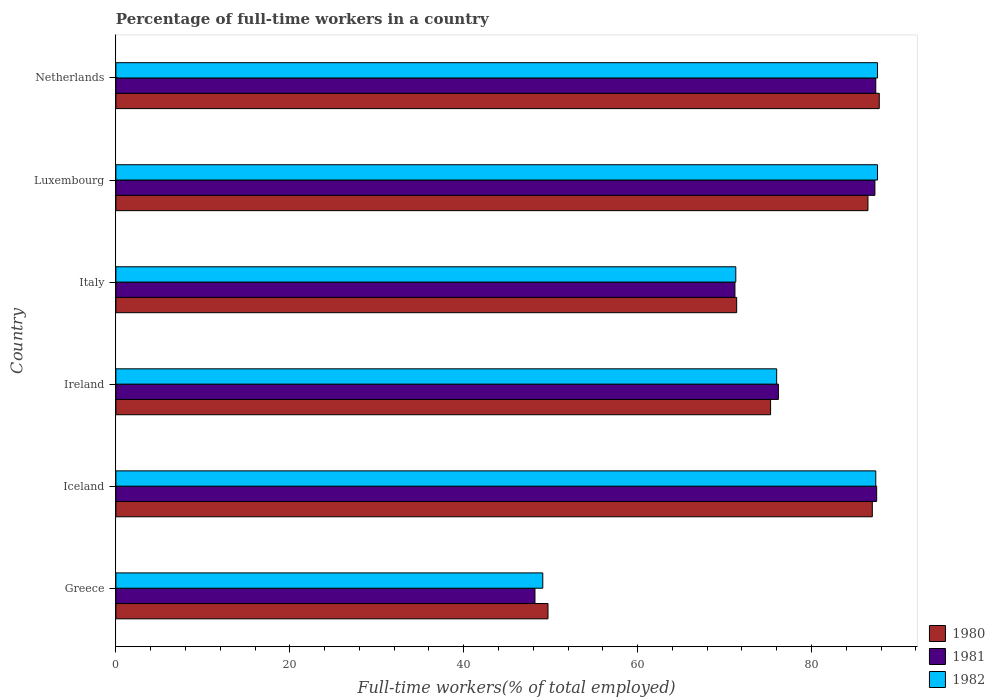Are the number of bars per tick equal to the number of legend labels?
Your answer should be compact. Yes. How many bars are there on the 4th tick from the top?
Ensure brevity in your answer.  3. How many bars are there on the 5th tick from the bottom?
Offer a very short reply. 3. What is the label of the 2nd group of bars from the top?
Your answer should be compact. Luxembourg. What is the percentage of full-time workers in 1981 in Greece?
Make the answer very short. 48.2. Across all countries, what is the maximum percentage of full-time workers in 1982?
Offer a terse response. 87.6. Across all countries, what is the minimum percentage of full-time workers in 1981?
Keep it short and to the point. 48.2. In which country was the percentage of full-time workers in 1980 maximum?
Keep it short and to the point. Netherlands. In which country was the percentage of full-time workers in 1982 minimum?
Ensure brevity in your answer.  Greece. What is the total percentage of full-time workers in 1980 in the graph?
Your answer should be compact. 457.7. What is the difference between the percentage of full-time workers in 1981 in Iceland and that in Ireland?
Your answer should be compact. 11.3. What is the difference between the percentage of full-time workers in 1981 in Italy and the percentage of full-time workers in 1982 in Netherlands?
Make the answer very short. -16.4. What is the average percentage of full-time workers in 1980 per country?
Offer a terse response. 76.28. What is the difference between the percentage of full-time workers in 1981 and percentage of full-time workers in 1980 in Luxembourg?
Provide a succinct answer. 0.8. In how many countries, is the percentage of full-time workers in 1981 greater than 12 %?
Your answer should be compact. 6. What is the ratio of the percentage of full-time workers in 1982 in Greece to that in Italy?
Offer a terse response. 0.69. Is the difference between the percentage of full-time workers in 1981 in Greece and Italy greater than the difference between the percentage of full-time workers in 1980 in Greece and Italy?
Provide a succinct answer. No. What is the difference between the highest and the second highest percentage of full-time workers in 1980?
Keep it short and to the point. 0.8. What is the difference between the highest and the lowest percentage of full-time workers in 1982?
Make the answer very short. 38.5. Is the sum of the percentage of full-time workers in 1980 in Italy and Luxembourg greater than the maximum percentage of full-time workers in 1981 across all countries?
Offer a terse response. Yes. Is it the case that in every country, the sum of the percentage of full-time workers in 1982 and percentage of full-time workers in 1981 is greater than the percentage of full-time workers in 1980?
Provide a succinct answer. Yes. How many bars are there?
Keep it short and to the point. 18. How many countries are there in the graph?
Ensure brevity in your answer.  6. What is the difference between two consecutive major ticks on the X-axis?
Your answer should be compact. 20. Does the graph contain any zero values?
Offer a terse response. No. How are the legend labels stacked?
Your answer should be very brief. Vertical. What is the title of the graph?
Offer a terse response. Percentage of full-time workers in a country. Does "2002" appear as one of the legend labels in the graph?
Give a very brief answer. No. What is the label or title of the X-axis?
Give a very brief answer. Full-time workers(% of total employed). What is the label or title of the Y-axis?
Your answer should be compact. Country. What is the Full-time workers(% of total employed) of 1980 in Greece?
Offer a terse response. 49.7. What is the Full-time workers(% of total employed) of 1981 in Greece?
Offer a terse response. 48.2. What is the Full-time workers(% of total employed) of 1982 in Greece?
Provide a succinct answer. 49.1. What is the Full-time workers(% of total employed) of 1981 in Iceland?
Make the answer very short. 87.5. What is the Full-time workers(% of total employed) of 1982 in Iceland?
Keep it short and to the point. 87.4. What is the Full-time workers(% of total employed) of 1980 in Ireland?
Your answer should be very brief. 75.3. What is the Full-time workers(% of total employed) in 1981 in Ireland?
Offer a very short reply. 76.2. What is the Full-time workers(% of total employed) of 1980 in Italy?
Provide a succinct answer. 71.4. What is the Full-time workers(% of total employed) of 1981 in Italy?
Keep it short and to the point. 71.2. What is the Full-time workers(% of total employed) of 1982 in Italy?
Keep it short and to the point. 71.3. What is the Full-time workers(% of total employed) of 1980 in Luxembourg?
Make the answer very short. 86.5. What is the Full-time workers(% of total employed) in 1981 in Luxembourg?
Give a very brief answer. 87.3. What is the Full-time workers(% of total employed) of 1982 in Luxembourg?
Offer a very short reply. 87.6. What is the Full-time workers(% of total employed) in 1980 in Netherlands?
Offer a terse response. 87.8. What is the Full-time workers(% of total employed) of 1981 in Netherlands?
Your response must be concise. 87.4. What is the Full-time workers(% of total employed) in 1982 in Netherlands?
Make the answer very short. 87.6. Across all countries, what is the maximum Full-time workers(% of total employed) of 1980?
Ensure brevity in your answer.  87.8. Across all countries, what is the maximum Full-time workers(% of total employed) of 1981?
Give a very brief answer. 87.5. Across all countries, what is the maximum Full-time workers(% of total employed) of 1982?
Your answer should be very brief. 87.6. Across all countries, what is the minimum Full-time workers(% of total employed) of 1980?
Offer a very short reply. 49.7. Across all countries, what is the minimum Full-time workers(% of total employed) in 1981?
Your answer should be very brief. 48.2. Across all countries, what is the minimum Full-time workers(% of total employed) in 1982?
Make the answer very short. 49.1. What is the total Full-time workers(% of total employed) of 1980 in the graph?
Your response must be concise. 457.7. What is the total Full-time workers(% of total employed) of 1981 in the graph?
Your answer should be very brief. 457.8. What is the total Full-time workers(% of total employed) of 1982 in the graph?
Your answer should be compact. 459. What is the difference between the Full-time workers(% of total employed) of 1980 in Greece and that in Iceland?
Make the answer very short. -37.3. What is the difference between the Full-time workers(% of total employed) of 1981 in Greece and that in Iceland?
Your answer should be compact. -39.3. What is the difference between the Full-time workers(% of total employed) in 1982 in Greece and that in Iceland?
Give a very brief answer. -38.3. What is the difference between the Full-time workers(% of total employed) in 1980 in Greece and that in Ireland?
Offer a very short reply. -25.6. What is the difference between the Full-time workers(% of total employed) in 1982 in Greece and that in Ireland?
Make the answer very short. -26.9. What is the difference between the Full-time workers(% of total employed) of 1980 in Greece and that in Italy?
Provide a succinct answer. -21.7. What is the difference between the Full-time workers(% of total employed) of 1982 in Greece and that in Italy?
Provide a short and direct response. -22.2. What is the difference between the Full-time workers(% of total employed) of 1980 in Greece and that in Luxembourg?
Ensure brevity in your answer.  -36.8. What is the difference between the Full-time workers(% of total employed) in 1981 in Greece and that in Luxembourg?
Offer a very short reply. -39.1. What is the difference between the Full-time workers(% of total employed) in 1982 in Greece and that in Luxembourg?
Make the answer very short. -38.5. What is the difference between the Full-time workers(% of total employed) in 1980 in Greece and that in Netherlands?
Your answer should be very brief. -38.1. What is the difference between the Full-time workers(% of total employed) of 1981 in Greece and that in Netherlands?
Your response must be concise. -39.2. What is the difference between the Full-time workers(% of total employed) in 1982 in Greece and that in Netherlands?
Provide a succinct answer. -38.5. What is the difference between the Full-time workers(% of total employed) of 1981 in Iceland and that in Ireland?
Give a very brief answer. 11.3. What is the difference between the Full-time workers(% of total employed) in 1982 in Iceland and that in Ireland?
Ensure brevity in your answer.  11.4. What is the difference between the Full-time workers(% of total employed) in 1981 in Iceland and that in Italy?
Make the answer very short. 16.3. What is the difference between the Full-time workers(% of total employed) in 1980 in Iceland and that in Luxembourg?
Provide a short and direct response. 0.5. What is the difference between the Full-time workers(% of total employed) of 1981 in Iceland and that in Luxembourg?
Give a very brief answer. 0.2. What is the difference between the Full-time workers(% of total employed) of 1980 in Iceland and that in Netherlands?
Give a very brief answer. -0.8. What is the difference between the Full-time workers(% of total employed) of 1981 in Iceland and that in Netherlands?
Offer a very short reply. 0.1. What is the difference between the Full-time workers(% of total employed) of 1980 in Ireland and that in Italy?
Give a very brief answer. 3.9. What is the difference between the Full-time workers(% of total employed) of 1981 in Ireland and that in Italy?
Your response must be concise. 5. What is the difference between the Full-time workers(% of total employed) in 1982 in Ireland and that in Italy?
Make the answer very short. 4.7. What is the difference between the Full-time workers(% of total employed) in 1980 in Ireland and that in Luxembourg?
Provide a succinct answer. -11.2. What is the difference between the Full-time workers(% of total employed) of 1982 in Ireland and that in Luxembourg?
Ensure brevity in your answer.  -11.6. What is the difference between the Full-time workers(% of total employed) of 1980 in Ireland and that in Netherlands?
Make the answer very short. -12.5. What is the difference between the Full-time workers(% of total employed) of 1982 in Ireland and that in Netherlands?
Your answer should be very brief. -11.6. What is the difference between the Full-time workers(% of total employed) of 1980 in Italy and that in Luxembourg?
Provide a short and direct response. -15.1. What is the difference between the Full-time workers(% of total employed) in 1981 in Italy and that in Luxembourg?
Give a very brief answer. -16.1. What is the difference between the Full-time workers(% of total employed) in 1982 in Italy and that in Luxembourg?
Give a very brief answer. -16.3. What is the difference between the Full-time workers(% of total employed) of 1980 in Italy and that in Netherlands?
Offer a very short reply. -16.4. What is the difference between the Full-time workers(% of total employed) of 1981 in Italy and that in Netherlands?
Offer a very short reply. -16.2. What is the difference between the Full-time workers(% of total employed) in 1982 in Italy and that in Netherlands?
Provide a succinct answer. -16.3. What is the difference between the Full-time workers(% of total employed) in 1980 in Luxembourg and that in Netherlands?
Give a very brief answer. -1.3. What is the difference between the Full-time workers(% of total employed) in 1982 in Luxembourg and that in Netherlands?
Give a very brief answer. 0. What is the difference between the Full-time workers(% of total employed) of 1980 in Greece and the Full-time workers(% of total employed) of 1981 in Iceland?
Offer a very short reply. -37.8. What is the difference between the Full-time workers(% of total employed) in 1980 in Greece and the Full-time workers(% of total employed) in 1982 in Iceland?
Keep it short and to the point. -37.7. What is the difference between the Full-time workers(% of total employed) of 1981 in Greece and the Full-time workers(% of total employed) of 1982 in Iceland?
Your answer should be compact. -39.2. What is the difference between the Full-time workers(% of total employed) in 1980 in Greece and the Full-time workers(% of total employed) in 1981 in Ireland?
Your answer should be very brief. -26.5. What is the difference between the Full-time workers(% of total employed) in 1980 in Greece and the Full-time workers(% of total employed) in 1982 in Ireland?
Make the answer very short. -26.3. What is the difference between the Full-time workers(% of total employed) in 1981 in Greece and the Full-time workers(% of total employed) in 1982 in Ireland?
Provide a succinct answer. -27.8. What is the difference between the Full-time workers(% of total employed) of 1980 in Greece and the Full-time workers(% of total employed) of 1981 in Italy?
Ensure brevity in your answer.  -21.5. What is the difference between the Full-time workers(% of total employed) in 1980 in Greece and the Full-time workers(% of total employed) in 1982 in Italy?
Make the answer very short. -21.6. What is the difference between the Full-time workers(% of total employed) in 1981 in Greece and the Full-time workers(% of total employed) in 1982 in Italy?
Your answer should be very brief. -23.1. What is the difference between the Full-time workers(% of total employed) in 1980 in Greece and the Full-time workers(% of total employed) in 1981 in Luxembourg?
Your answer should be compact. -37.6. What is the difference between the Full-time workers(% of total employed) of 1980 in Greece and the Full-time workers(% of total employed) of 1982 in Luxembourg?
Make the answer very short. -37.9. What is the difference between the Full-time workers(% of total employed) of 1981 in Greece and the Full-time workers(% of total employed) of 1982 in Luxembourg?
Make the answer very short. -39.4. What is the difference between the Full-time workers(% of total employed) of 1980 in Greece and the Full-time workers(% of total employed) of 1981 in Netherlands?
Keep it short and to the point. -37.7. What is the difference between the Full-time workers(% of total employed) of 1980 in Greece and the Full-time workers(% of total employed) of 1982 in Netherlands?
Your answer should be very brief. -37.9. What is the difference between the Full-time workers(% of total employed) in 1981 in Greece and the Full-time workers(% of total employed) in 1982 in Netherlands?
Offer a very short reply. -39.4. What is the difference between the Full-time workers(% of total employed) of 1980 in Iceland and the Full-time workers(% of total employed) of 1981 in Italy?
Provide a short and direct response. 15.8. What is the difference between the Full-time workers(% of total employed) of 1981 in Iceland and the Full-time workers(% of total employed) of 1982 in Italy?
Give a very brief answer. 16.2. What is the difference between the Full-time workers(% of total employed) of 1980 in Iceland and the Full-time workers(% of total employed) of 1981 in Luxembourg?
Keep it short and to the point. -0.3. What is the difference between the Full-time workers(% of total employed) in 1981 in Iceland and the Full-time workers(% of total employed) in 1982 in Luxembourg?
Offer a very short reply. -0.1. What is the difference between the Full-time workers(% of total employed) of 1981 in Ireland and the Full-time workers(% of total employed) of 1982 in Italy?
Your answer should be compact. 4.9. What is the difference between the Full-time workers(% of total employed) of 1981 in Ireland and the Full-time workers(% of total employed) of 1982 in Netherlands?
Make the answer very short. -11.4. What is the difference between the Full-time workers(% of total employed) in 1980 in Italy and the Full-time workers(% of total employed) in 1981 in Luxembourg?
Make the answer very short. -15.9. What is the difference between the Full-time workers(% of total employed) of 1980 in Italy and the Full-time workers(% of total employed) of 1982 in Luxembourg?
Offer a very short reply. -16.2. What is the difference between the Full-time workers(% of total employed) in 1981 in Italy and the Full-time workers(% of total employed) in 1982 in Luxembourg?
Provide a short and direct response. -16.4. What is the difference between the Full-time workers(% of total employed) in 1980 in Italy and the Full-time workers(% of total employed) in 1981 in Netherlands?
Your answer should be compact. -16. What is the difference between the Full-time workers(% of total employed) in 1980 in Italy and the Full-time workers(% of total employed) in 1982 in Netherlands?
Ensure brevity in your answer.  -16.2. What is the difference between the Full-time workers(% of total employed) in 1981 in Italy and the Full-time workers(% of total employed) in 1982 in Netherlands?
Your answer should be compact. -16.4. What is the difference between the Full-time workers(% of total employed) in 1980 in Luxembourg and the Full-time workers(% of total employed) in 1982 in Netherlands?
Your response must be concise. -1.1. What is the average Full-time workers(% of total employed) in 1980 per country?
Your response must be concise. 76.28. What is the average Full-time workers(% of total employed) of 1981 per country?
Give a very brief answer. 76.3. What is the average Full-time workers(% of total employed) in 1982 per country?
Your answer should be compact. 76.5. What is the difference between the Full-time workers(% of total employed) of 1980 and Full-time workers(% of total employed) of 1981 in Greece?
Keep it short and to the point. 1.5. What is the difference between the Full-time workers(% of total employed) of 1980 and Full-time workers(% of total employed) of 1982 in Greece?
Provide a short and direct response. 0.6. What is the difference between the Full-time workers(% of total employed) of 1981 and Full-time workers(% of total employed) of 1982 in Greece?
Offer a very short reply. -0.9. What is the difference between the Full-time workers(% of total employed) of 1980 and Full-time workers(% of total employed) of 1982 in Iceland?
Provide a short and direct response. -0.4. What is the difference between the Full-time workers(% of total employed) in 1980 and Full-time workers(% of total employed) in 1982 in Ireland?
Provide a succinct answer. -0.7. What is the difference between the Full-time workers(% of total employed) of 1980 and Full-time workers(% of total employed) of 1981 in Italy?
Ensure brevity in your answer.  0.2. What is the difference between the Full-time workers(% of total employed) of 1980 and Full-time workers(% of total employed) of 1982 in Italy?
Ensure brevity in your answer.  0.1. What is the difference between the Full-time workers(% of total employed) in 1980 and Full-time workers(% of total employed) in 1981 in Luxembourg?
Offer a very short reply. -0.8. What is the difference between the Full-time workers(% of total employed) in 1980 and Full-time workers(% of total employed) in 1982 in Luxembourg?
Your response must be concise. -1.1. What is the difference between the Full-time workers(% of total employed) of 1981 and Full-time workers(% of total employed) of 1982 in Luxembourg?
Your answer should be compact. -0.3. What is the difference between the Full-time workers(% of total employed) in 1980 and Full-time workers(% of total employed) in 1981 in Netherlands?
Your answer should be very brief. 0.4. What is the ratio of the Full-time workers(% of total employed) in 1980 in Greece to that in Iceland?
Give a very brief answer. 0.57. What is the ratio of the Full-time workers(% of total employed) of 1981 in Greece to that in Iceland?
Make the answer very short. 0.55. What is the ratio of the Full-time workers(% of total employed) in 1982 in Greece to that in Iceland?
Your answer should be very brief. 0.56. What is the ratio of the Full-time workers(% of total employed) in 1980 in Greece to that in Ireland?
Offer a very short reply. 0.66. What is the ratio of the Full-time workers(% of total employed) of 1981 in Greece to that in Ireland?
Offer a very short reply. 0.63. What is the ratio of the Full-time workers(% of total employed) of 1982 in Greece to that in Ireland?
Offer a terse response. 0.65. What is the ratio of the Full-time workers(% of total employed) of 1980 in Greece to that in Italy?
Offer a very short reply. 0.7. What is the ratio of the Full-time workers(% of total employed) of 1981 in Greece to that in Italy?
Ensure brevity in your answer.  0.68. What is the ratio of the Full-time workers(% of total employed) in 1982 in Greece to that in Italy?
Your answer should be very brief. 0.69. What is the ratio of the Full-time workers(% of total employed) in 1980 in Greece to that in Luxembourg?
Offer a terse response. 0.57. What is the ratio of the Full-time workers(% of total employed) of 1981 in Greece to that in Luxembourg?
Your response must be concise. 0.55. What is the ratio of the Full-time workers(% of total employed) in 1982 in Greece to that in Luxembourg?
Give a very brief answer. 0.56. What is the ratio of the Full-time workers(% of total employed) in 1980 in Greece to that in Netherlands?
Your answer should be compact. 0.57. What is the ratio of the Full-time workers(% of total employed) in 1981 in Greece to that in Netherlands?
Your answer should be very brief. 0.55. What is the ratio of the Full-time workers(% of total employed) of 1982 in Greece to that in Netherlands?
Give a very brief answer. 0.56. What is the ratio of the Full-time workers(% of total employed) of 1980 in Iceland to that in Ireland?
Your answer should be very brief. 1.16. What is the ratio of the Full-time workers(% of total employed) in 1981 in Iceland to that in Ireland?
Your answer should be compact. 1.15. What is the ratio of the Full-time workers(% of total employed) of 1982 in Iceland to that in Ireland?
Keep it short and to the point. 1.15. What is the ratio of the Full-time workers(% of total employed) in 1980 in Iceland to that in Italy?
Offer a very short reply. 1.22. What is the ratio of the Full-time workers(% of total employed) of 1981 in Iceland to that in Italy?
Offer a very short reply. 1.23. What is the ratio of the Full-time workers(% of total employed) in 1982 in Iceland to that in Italy?
Provide a succinct answer. 1.23. What is the ratio of the Full-time workers(% of total employed) in 1981 in Iceland to that in Luxembourg?
Your answer should be very brief. 1. What is the ratio of the Full-time workers(% of total employed) of 1982 in Iceland to that in Luxembourg?
Your answer should be very brief. 1. What is the ratio of the Full-time workers(% of total employed) in 1980 in Iceland to that in Netherlands?
Your answer should be compact. 0.99. What is the ratio of the Full-time workers(% of total employed) of 1980 in Ireland to that in Italy?
Offer a terse response. 1.05. What is the ratio of the Full-time workers(% of total employed) of 1981 in Ireland to that in Italy?
Your answer should be compact. 1.07. What is the ratio of the Full-time workers(% of total employed) of 1982 in Ireland to that in Italy?
Provide a short and direct response. 1.07. What is the ratio of the Full-time workers(% of total employed) of 1980 in Ireland to that in Luxembourg?
Offer a terse response. 0.87. What is the ratio of the Full-time workers(% of total employed) of 1981 in Ireland to that in Luxembourg?
Your answer should be very brief. 0.87. What is the ratio of the Full-time workers(% of total employed) of 1982 in Ireland to that in Luxembourg?
Your response must be concise. 0.87. What is the ratio of the Full-time workers(% of total employed) in 1980 in Ireland to that in Netherlands?
Provide a succinct answer. 0.86. What is the ratio of the Full-time workers(% of total employed) in 1981 in Ireland to that in Netherlands?
Give a very brief answer. 0.87. What is the ratio of the Full-time workers(% of total employed) in 1982 in Ireland to that in Netherlands?
Offer a very short reply. 0.87. What is the ratio of the Full-time workers(% of total employed) in 1980 in Italy to that in Luxembourg?
Ensure brevity in your answer.  0.83. What is the ratio of the Full-time workers(% of total employed) in 1981 in Italy to that in Luxembourg?
Provide a short and direct response. 0.82. What is the ratio of the Full-time workers(% of total employed) of 1982 in Italy to that in Luxembourg?
Your response must be concise. 0.81. What is the ratio of the Full-time workers(% of total employed) in 1980 in Italy to that in Netherlands?
Keep it short and to the point. 0.81. What is the ratio of the Full-time workers(% of total employed) of 1981 in Italy to that in Netherlands?
Give a very brief answer. 0.81. What is the ratio of the Full-time workers(% of total employed) in 1982 in Italy to that in Netherlands?
Make the answer very short. 0.81. What is the ratio of the Full-time workers(% of total employed) in 1980 in Luxembourg to that in Netherlands?
Keep it short and to the point. 0.99. What is the difference between the highest and the second highest Full-time workers(% of total employed) of 1980?
Keep it short and to the point. 0.8. What is the difference between the highest and the second highest Full-time workers(% of total employed) of 1981?
Provide a succinct answer. 0.1. What is the difference between the highest and the second highest Full-time workers(% of total employed) in 1982?
Offer a very short reply. 0. What is the difference between the highest and the lowest Full-time workers(% of total employed) of 1980?
Give a very brief answer. 38.1. What is the difference between the highest and the lowest Full-time workers(% of total employed) in 1981?
Your answer should be very brief. 39.3. What is the difference between the highest and the lowest Full-time workers(% of total employed) of 1982?
Offer a very short reply. 38.5. 